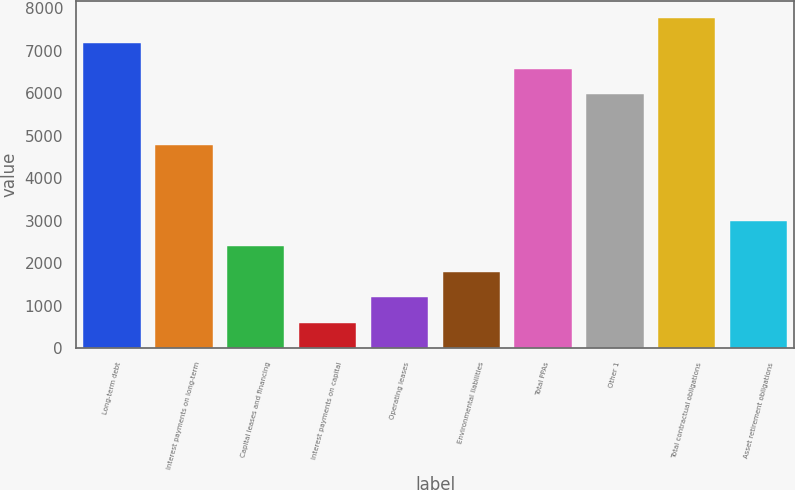Convert chart to OTSL. <chart><loc_0><loc_0><loc_500><loc_500><bar_chart><fcel>Long-term debt<fcel>Interest payments on long-term<fcel>Capital leases and financing<fcel>Interest payments on capital<fcel>Operating leases<fcel>Environmental liabilities<fcel>Total PPAs<fcel>Other 1<fcel>Total contractual obligations<fcel>Asset retirement obligations<nl><fcel>7176.8<fcel>4787.2<fcel>2397.6<fcel>605.4<fcel>1202.8<fcel>1800.2<fcel>6579.4<fcel>5982<fcel>7774.2<fcel>2995<nl></chart> 